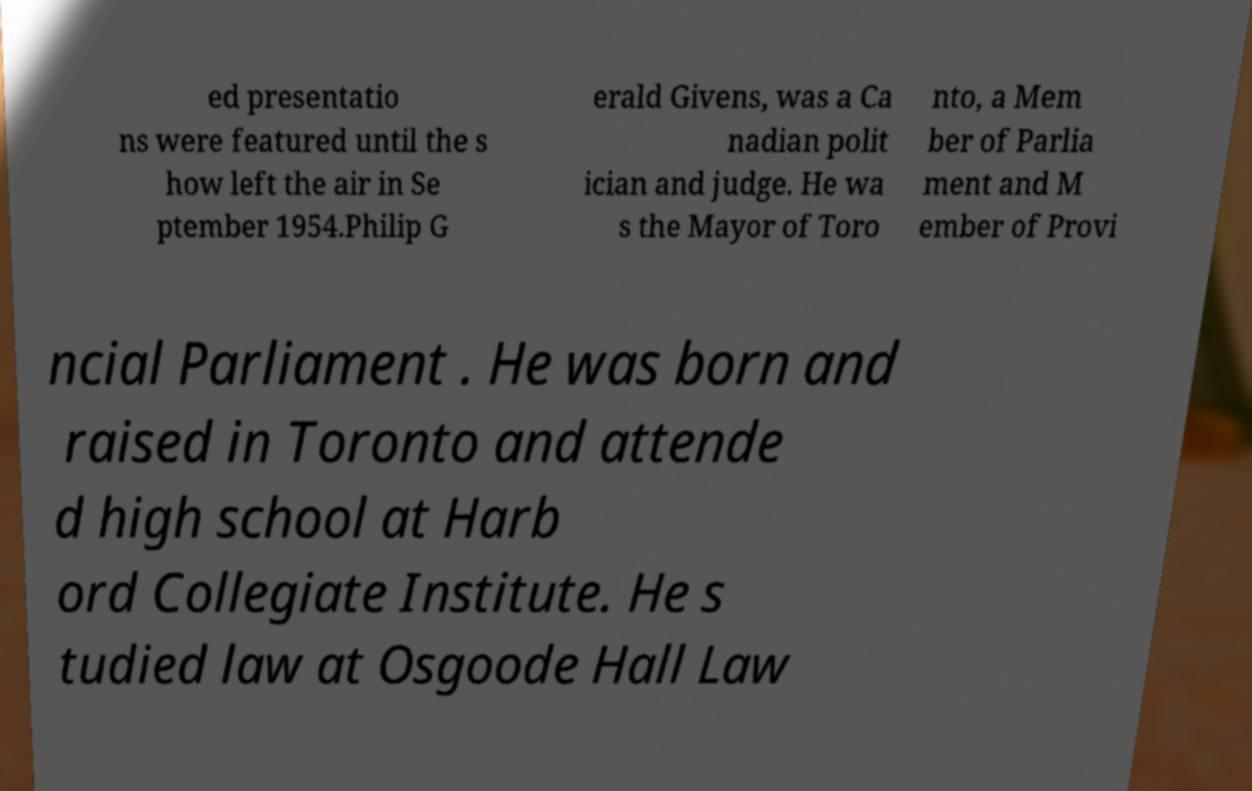There's text embedded in this image that I need extracted. Can you transcribe it verbatim? ed presentatio ns were featured until the s how left the air in Se ptember 1954.Philip G erald Givens, was a Ca nadian polit ician and judge. He wa s the Mayor of Toro nto, a Mem ber of Parlia ment and M ember of Provi ncial Parliament . He was born and raised in Toronto and attende d high school at Harb ord Collegiate Institute. He s tudied law at Osgoode Hall Law 